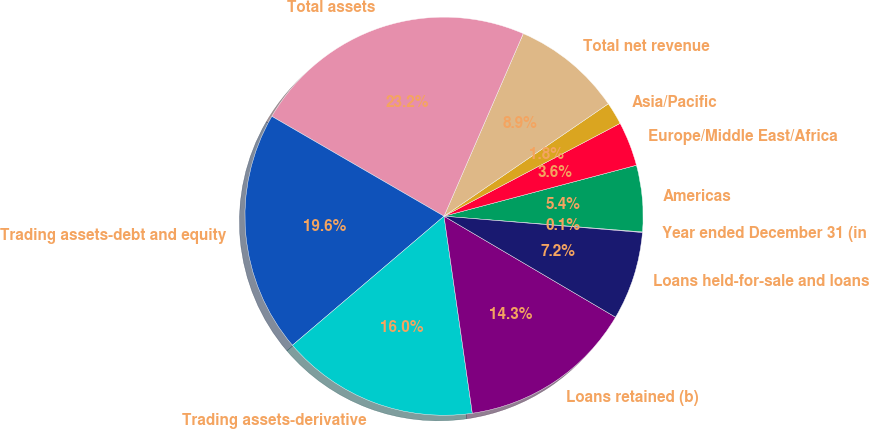Convert chart to OTSL. <chart><loc_0><loc_0><loc_500><loc_500><pie_chart><fcel>Year ended December 31 (in<fcel>Americas<fcel>Europe/Middle East/Africa<fcel>Asia/Pacific<fcel>Total net revenue<fcel>Total assets<fcel>Trading assets-debt and equity<fcel>Trading assets-derivative<fcel>Loans retained (b)<fcel>Loans held-for-sale and loans<nl><fcel>0.05%<fcel>5.38%<fcel>3.6%<fcel>1.83%<fcel>8.93%<fcel>23.15%<fcel>19.59%<fcel>16.04%<fcel>14.26%<fcel>7.16%<nl></chart> 